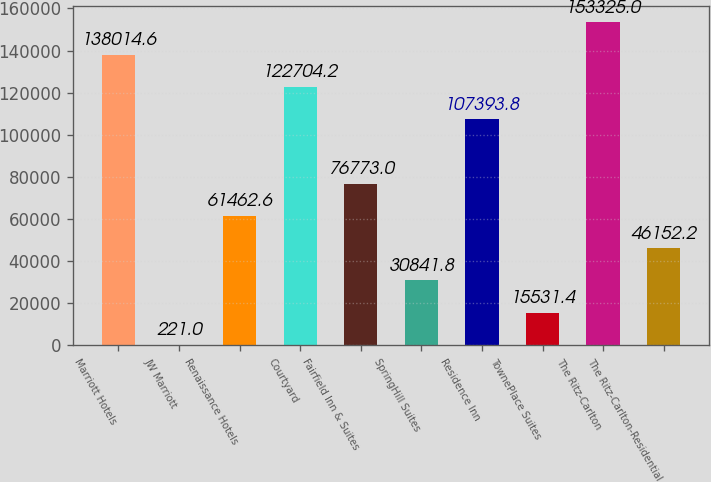Convert chart to OTSL. <chart><loc_0><loc_0><loc_500><loc_500><bar_chart><fcel>Marriott Hotels<fcel>JW Marriott<fcel>Renaissance Hotels<fcel>Courtyard<fcel>Fairfield Inn & Suites<fcel>SpringHill Suites<fcel>Residence Inn<fcel>TownePlace Suites<fcel>The Ritz-Carlton<fcel>The Ritz-Carlton-Residential<nl><fcel>138015<fcel>221<fcel>61462.6<fcel>122704<fcel>76773<fcel>30841.8<fcel>107394<fcel>15531.4<fcel>153325<fcel>46152.2<nl></chart> 